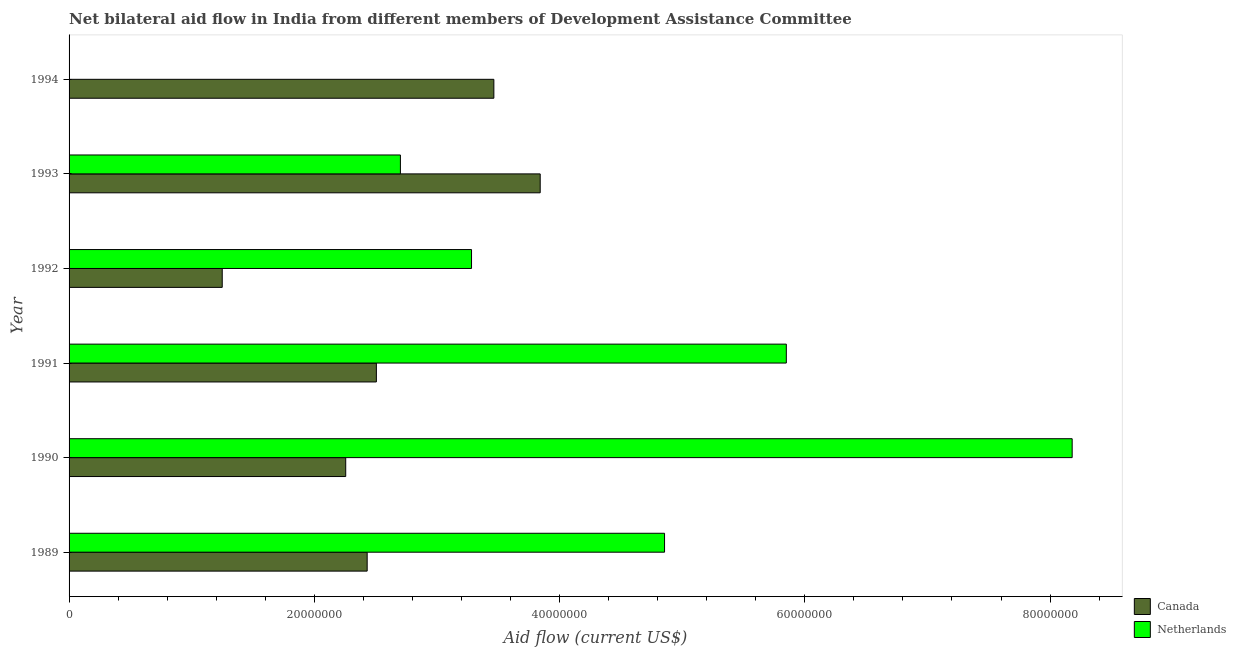Are the number of bars per tick equal to the number of legend labels?
Make the answer very short. No. Are the number of bars on each tick of the Y-axis equal?
Your answer should be compact. No. How many bars are there on the 3rd tick from the bottom?
Provide a short and direct response. 2. What is the label of the 6th group of bars from the top?
Your answer should be very brief. 1989. What is the amount of aid given by netherlands in 1993?
Your response must be concise. 2.70e+07. Across all years, what is the maximum amount of aid given by netherlands?
Provide a short and direct response. 8.18e+07. What is the total amount of aid given by netherlands in the graph?
Your answer should be compact. 2.49e+08. What is the difference between the amount of aid given by canada in 1990 and that in 1993?
Make the answer very short. -1.59e+07. What is the difference between the amount of aid given by canada in 1989 and the amount of aid given by netherlands in 1994?
Offer a very short reply. 2.43e+07. What is the average amount of aid given by netherlands per year?
Provide a succinct answer. 4.14e+07. In the year 1992, what is the difference between the amount of aid given by netherlands and amount of aid given by canada?
Make the answer very short. 2.03e+07. In how many years, is the amount of aid given by netherlands greater than 4000000 US$?
Your response must be concise. 5. What is the ratio of the amount of aid given by canada in 1992 to that in 1993?
Give a very brief answer. 0.33. Is the amount of aid given by canada in 1991 less than that in 1992?
Your response must be concise. No. What is the difference between the highest and the second highest amount of aid given by netherlands?
Make the answer very short. 2.33e+07. What is the difference between the highest and the lowest amount of aid given by canada?
Offer a terse response. 2.59e+07. How many bars are there?
Give a very brief answer. 11. Are all the bars in the graph horizontal?
Provide a short and direct response. Yes. How many years are there in the graph?
Keep it short and to the point. 6. What is the difference between two consecutive major ticks on the X-axis?
Provide a succinct answer. 2.00e+07. Are the values on the major ticks of X-axis written in scientific E-notation?
Your response must be concise. No. Does the graph contain grids?
Keep it short and to the point. No. What is the title of the graph?
Your response must be concise. Net bilateral aid flow in India from different members of Development Assistance Committee. What is the Aid flow (current US$) of Canada in 1989?
Your answer should be very brief. 2.43e+07. What is the Aid flow (current US$) of Netherlands in 1989?
Offer a terse response. 4.86e+07. What is the Aid flow (current US$) of Canada in 1990?
Offer a very short reply. 2.26e+07. What is the Aid flow (current US$) of Netherlands in 1990?
Provide a short and direct response. 8.18e+07. What is the Aid flow (current US$) of Canada in 1991?
Your answer should be very brief. 2.51e+07. What is the Aid flow (current US$) of Netherlands in 1991?
Give a very brief answer. 5.85e+07. What is the Aid flow (current US$) in Canada in 1992?
Provide a succinct answer. 1.25e+07. What is the Aid flow (current US$) in Netherlands in 1992?
Make the answer very short. 3.28e+07. What is the Aid flow (current US$) in Canada in 1993?
Your answer should be very brief. 3.84e+07. What is the Aid flow (current US$) in Netherlands in 1993?
Your answer should be very brief. 2.70e+07. What is the Aid flow (current US$) in Canada in 1994?
Your response must be concise. 3.46e+07. What is the Aid flow (current US$) in Netherlands in 1994?
Provide a succinct answer. 0. Across all years, what is the maximum Aid flow (current US$) in Canada?
Your answer should be compact. 3.84e+07. Across all years, what is the maximum Aid flow (current US$) of Netherlands?
Keep it short and to the point. 8.18e+07. Across all years, what is the minimum Aid flow (current US$) in Canada?
Offer a terse response. 1.25e+07. What is the total Aid flow (current US$) in Canada in the graph?
Keep it short and to the point. 1.57e+08. What is the total Aid flow (current US$) in Netherlands in the graph?
Offer a terse response. 2.49e+08. What is the difference between the Aid flow (current US$) of Canada in 1989 and that in 1990?
Your answer should be compact. 1.75e+06. What is the difference between the Aid flow (current US$) in Netherlands in 1989 and that in 1990?
Your answer should be very brief. -3.32e+07. What is the difference between the Aid flow (current US$) of Canada in 1989 and that in 1991?
Keep it short and to the point. -7.50e+05. What is the difference between the Aid flow (current US$) in Netherlands in 1989 and that in 1991?
Provide a short and direct response. -9.93e+06. What is the difference between the Aid flow (current US$) in Canada in 1989 and that in 1992?
Make the answer very short. 1.18e+07. What is the difference between the Aid flow (current US$) in Netherlands in 1989 and that in 1992?
Provide a short and direct response. 1.57e+07. What is the difference between the Aid flow (current US$) in Canada in 1989 and that in 1993?
Your answer should be very brief. -1.41e+07. What is the difference between the Aid flow (current US$) of Netherlands in 1989 and that in 1993?
Your response must be concise. 2.15e+07. What is the difference between the Aid flow (current US$) of Canada in 1989 and that in 1994?
Make the answer very short. -1.03e+07. What is the difference between the Aid flow (current US$) of Canada in 1990 and that in 1991?
Keep it short and to the point. -2.50e+06. What is the difference between the Aid flow (current US$) of Netherlands in 1990 and that in 1991?
Your response must be concise. 2.33e+07. What is the difference between the Aid flow (current US$) of Canada in 1990 and that in 1992?
Provide a short and direct response. 1.01e+07. What is the difference between the Aid flow (current US$) of Netherlands in 1990 and that in 1992?
Ensure brevity in your answer.  4.90e+07. What is the difference between the Aid flow (current US$) of Canada in 1990 and that in 1993?
Provide a short and direct response. -1.59e+07. What is the difference between the Aid flow (current US$) of Netherlands in 1990 and that in 1993?
Your answer should be very brief. 5.48e+07. What is the difference between the Aid flow (current US$) of Canada in 1990 and that in 1994?
Your answer should be very brief. -1.21e+07. What is the difference between the Aid flow (current US$) of Canada in 1991 and that in 1992?
Your response must be concise. 1.26e+07. What is the difference between the Aid flow (current US$) in Netherlands in 1991 and that in 1992?
Make the answer very short. 2.57e+07. What is the difference between the Aid flow (current US$) of Canada in 1991 and that in 1993?
Provide a short and direct response. -1.34e+07. What is the difference between the Aid flow (current US$) in Netherlands in 1991 and that in 1993?
Provide a succinct answer. 3.15e+07. What is the difference between the Aid flow (current US$) in Canada in 1991 and that in 1994?
Make the answer very short. -9.58e+06. What is the difference between the Aid flow (current US$) of Canada in 1992 and that in 1993?
Your answer should be compact. -2.59e+07. What is the difference between the Aid flow (current US$) of Netherlands in 1992 and that in 1993?
Provide a short and direct response. 5.80e+06. What is the difference between the Aid flow (current US$) of Canada in 1992 and that in 1994?
Your answer should be very brief. -2.22e+07. What is the difference between the Aid flow (current US$) in Canada in 1993 and that in 1994?
Your response must be concise. 3.78e+06. What is the difference between the Aid flow (current US$) of Canada in 1989 and the Aid flow (current US$) of Netherlands in 1990?
Ensure brevity in your answer.  -5.75e+07. What is the difference between the Aid flow (current US$) of Canada in 1989 and the Aid flow (current US$) of Netherlands in 1991?
Make the answer very short. -3.42e+07. What is the difference between the Aid flow (current US$) of Canada in 1989 and the Aid flow (current US$) of Netherlands in 1992?
Keep it short and to the point. -8.51e+06. What is the difference between the Aid flow (current US$) in Canada in 1989 and the Aid flow (current US$) in Netherlands in 1993?
Ensure brevity in your answer.  -2.71e+06. What is the difference between the Aid flow (current US$) in Canada in 1990 and the Aid flow (current US$) in Netherlands in 1991?
Give a very brief answer. -3.59e+07. What is the difference between the Aid flow (current US$) in Canada in 1990 and the Aid flow (current US$) in Netherlands in 1992?
Provide a short and direct response. -1.03e+07. What is the difference between the Aid flow (current US$) in Canada in 1990 and the Aid flow (current US$) in Netherlands in 1993?
Your answer should be very brief. -4.46e+06. What is the difference between the Aid flow (current US$) in Canada in 1991 and the Aid flow (current US$) in Netherlands in 1992?
Make the answer very short. -7.76e+06. What is the difference between the Aid flow (current US$) in Canada in 1991 and the Aid flow (current US$) in Netherlands in 1993?
Provide a short and direct response. -1.96e+06. What is the difference between the Aid flow (current US$) of Canada in 1992 and the Aid flow (current US$) of Netherlands in 1993?
Provide a succinct answer. -1.45e+07. What is the average Aid flow (current US$) of Canada per year?
Ensure brevity in your answer.  2.62e+07. What is the average Aid flow (current US$) of Netherlands per year?
Your answer should be compact. 4.14e+07. In the year 1989, what is the difference between the Aid flow (current US$) in Canada and Aid flow (current US$) in Netherlands?
Give a very brief answer. -2.42e+07. In the year 1990, what is the difference between the Aid flow (current US$) of Canada and Aid flow (current US$) of Netherlands?
Your response must be concise. -5.92e+07. In the year 1991, what is the difference between the Aid flow (current US$) of Canada and Aid flow (current US$) of Netherlands?
Give a very brief answer. -3.34e+07. In the year 1992, what is the difference between the Aid flow (current US$) in Canada and Aid flow (current US$) in Netherlands?
Your answer should be very brief. -2.03e+07. In the year 1993, what is the difference between the Aid flow (current US$) of Canada and Aid flow (current US$) of Netherlands?
Offer a very short reply. 1.14e+07. What is the ratio of the Aid flow (current US$) of Canada in 1989 to that in 1990?
Offer a terse response. 1.08. What is the ratio of the Aid flow (current US$) of Netherlands in 1989 to that in 1990?
Offer a terse response. 0.59. What is the ratio of the Aid flow (current US$) of Canada in 1989 to that in 1991?
Provide a short and direct response. 0.97. What is the ratio of the Aid flow (current US$) of Netherlands in 1989 to that in 1991?
Keep it short and to the point. 0.83. What is the ratio of the Aid flow (current US$) in Canada in 1989 to that in 1992?
Offer a terse response. 1.95. What is the ratio of the Aid flow (current US$) of Netherlands in 1989 to that in 1992?
Make the answer very short. 1.48. What is the ratio of the Aid flow (current US$) in Canada in 1989 to that in 1993?
Offer a very short reply. 0.63. What is the ratio of the Aid flow (current US$) in Netherlands in 1989 to that in 1993?
Your response must be concise. 1.8. What is the ratio of the Aid flow (current US$) of Canada in 1989 to that in 1994?
Ensure brevity in your answer.  0.7. What is the ratio of the Aid flow (current US$) in Canada in 1990 to that in 1991?
Keep it short and to the point. 0.9. What is the ratio of the Aid flow (current US$) in Netherlands in 1990 to that in 1991?
Your answer should be very brief. 1.4. What is the ratio of the Aid flow (current US$) of Canada in 1990 to that in 1992?
Provide a short and direct response. 1.81. What is the ratio of the Aid flow (current US$) of Netherlands in 1990 to that in 1992?
Keep it short and to the point. 2.49. What is the ratio of the Aid flow (current US$) of Canada in 1990 to that in 1993?
Ensure brevity in your answer.  0.59. What is the ratio of the Aid flow (current US$) of Netherlands in 1990 to that in 1993?
Give a very brief answer. 3.03. What is the ratio of the Aid flow (current US$) of Canada in 1990 to that in 1994?
Keep it short and to the point. 0.65. What is the ratio of the Aid flow (current US$) in Canada in 1991 to that in 1992?
Your answer should be very brief. 2.01. What is the ratio of the Aid flow (current US$) in Netherlands in 1991 to that in 1992?
Make the answer very short. 1.78. What is the ratio of the Aid flow (current US$) of Canada in 1991 to that in 1993?
Make the answer very short. 0.65. What is the ratio of the Aid flow (current US$) in Netherlands in 1991 to that in 1993?
Keep it short and to the point. 2.16. What is the ratio of the Aid flow (current US$) of Canada in 1991 to that in 1994?
Your answer should be very brief. 0.72. What is the ratio of the Aid flow (current US$) of Canada in 1992 to that in 1993?
Make the answer very short. 0.33. What is the ratio of the Aid flow (current US$) in Netherlands in 1992 to that in 1993?
Your answer should be compact. 1.21. What is the ratio of the Aid flow (current US$) in Canada in 1992 to that in 1994?
Your response must be concise. 0.36. What is the ratio of the Aid flow (current US$) in Canada in 1993 to that in 1994?
Your answer should be very brief. 1.11. What is the difference between the highest and the second highest Aid flow (current US$) in Canada?
Make the answer very short. 3.78e+06. What is the difference between the highest and the second highest Aid flow (current US$) in Netherlands?
Provide a succinct answer. 2.33e+07. What is the difference between the highest and the lowest Aid flow (current US$) of Canada?
Give a very brief answer. 2.59e+07. What is the difference between the highest and the lowest Aid flow (current US$) in Netherlands?
Make the answer very short. 8.18e+07. 